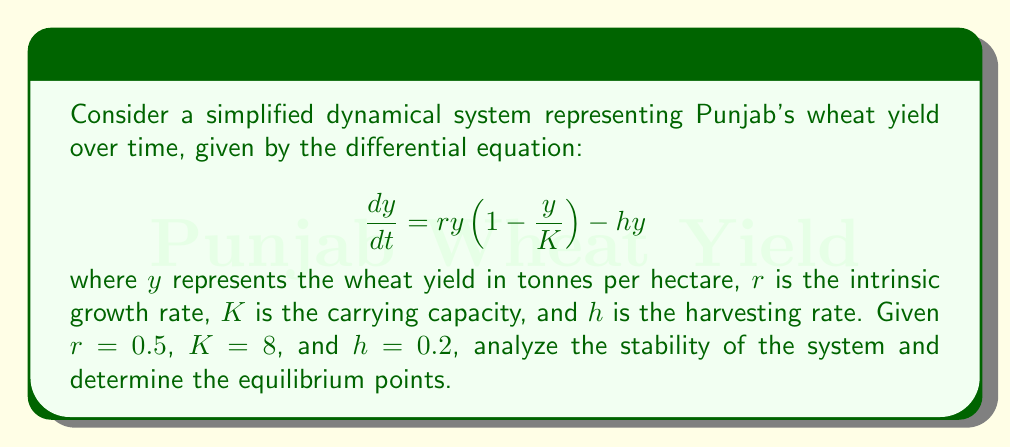Could you help me with this problem? 1. Find the equilibrium points by setting $\frac{dy}{dt} = 0$:

   $$0 = ry(1 - \frac{y}{K}) - hy$$
   $$0 = 0.5y(1 - \frac{y}{8}) - 0.2y$$
   $$0 = 0.5y - 0.0625y^2 - 0.2y$$
   $$0 = 0.3y - 0.0625y^2$$
   $$y(0.3 - 0.0625y) = 0$$

   Solving this equation gives us two equilibrium points:
   $y_1 = 0$ and $y_2 = 4.8$

2. Analyze the stability of each equilibrium point by finding the derivative of $\frac{dy}{dt}$ with respect to $y$:

   $$\frac{d}{dy}(\frac{dy}{dt}) = r(1 - \frac{2y}{K}) - h$$
   $$\frac{d}{dy}(\frac{dy}{dt}) = 0.5(1 - \frac{2y}{8}) - 0.2$$
   $$\frac{d}{dy}(\frac{dy}{dt}) = 0.5 - 0.125y - 0.2$$
   $$\frac{d}{dy}(\frac{dy}{dt}) = 0.3 - 0.125y$$

3. Evaluate the derivative at each equilibrium point:

   At $y_1 = 0$:
   $$0.3 - 0.125(0) = 0.3 > 0$$
   This indicates that $y_1 = 0$ is an unstable equilibrium point.

   At $y_2 = 4.8$:
   $$0.3 - 0.125(4.8) = -0.3 < 0$$
   This indicates that $y_2 = 4.8$ is a stable equilibrium point.

4. Interpret the results:
   The system has two equilibrium points: 0 and 4.8 tonnes per hectare. The zero equilibrium is unstable, meaning that if there's any wheat production, it will move away from zero. The 4.8 tonnes per hectare equilibrium is stable, indicating that the wheat yield will tend towards this value over time.
Answer: Two equilibrium points: $y_1 = 0$ (unstable) and $y_2 = 4.8$ (stable). 